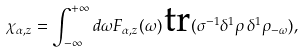<formula> <loc_0><loc_0><loc_500><loc_500>\chi _ { \alpha , z } = \int _ { - \infty } ^ { + \infty } d \omega F _ { \alpha , z } ( \omega ) \, \text {tr} ( \sigma ^ { - 1 } \delta ^ { 1 } \rho \, \delta ^ { 1 } \rho _ { - \omega } ) ,</formula> 